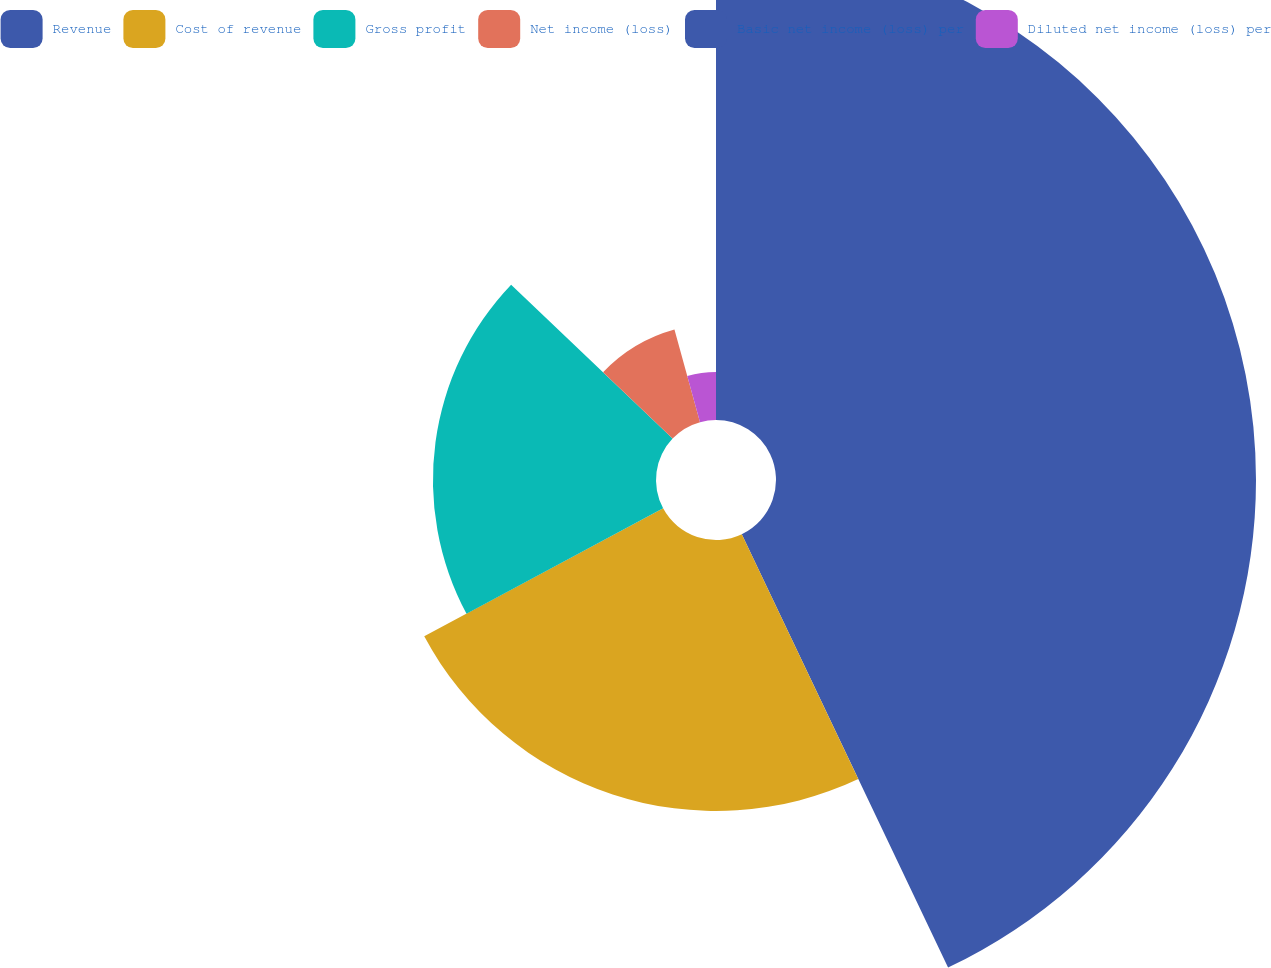<chart> <loc_0><loc_0><loc_500><loc_500><pie_chart><fcel>Revenue<fcel>Cost of revenue<fcel>Gross profit<fcel>Net income (loss)<fcel>Basic net income (loss) per<fcel>Diluted net income (loss) per<nl><fcel>42.93%<fcel>24.24%<fcel>19.95%<fcel>8.59%<fcel>0.0%<fcel>4.29%<nl></chart> 